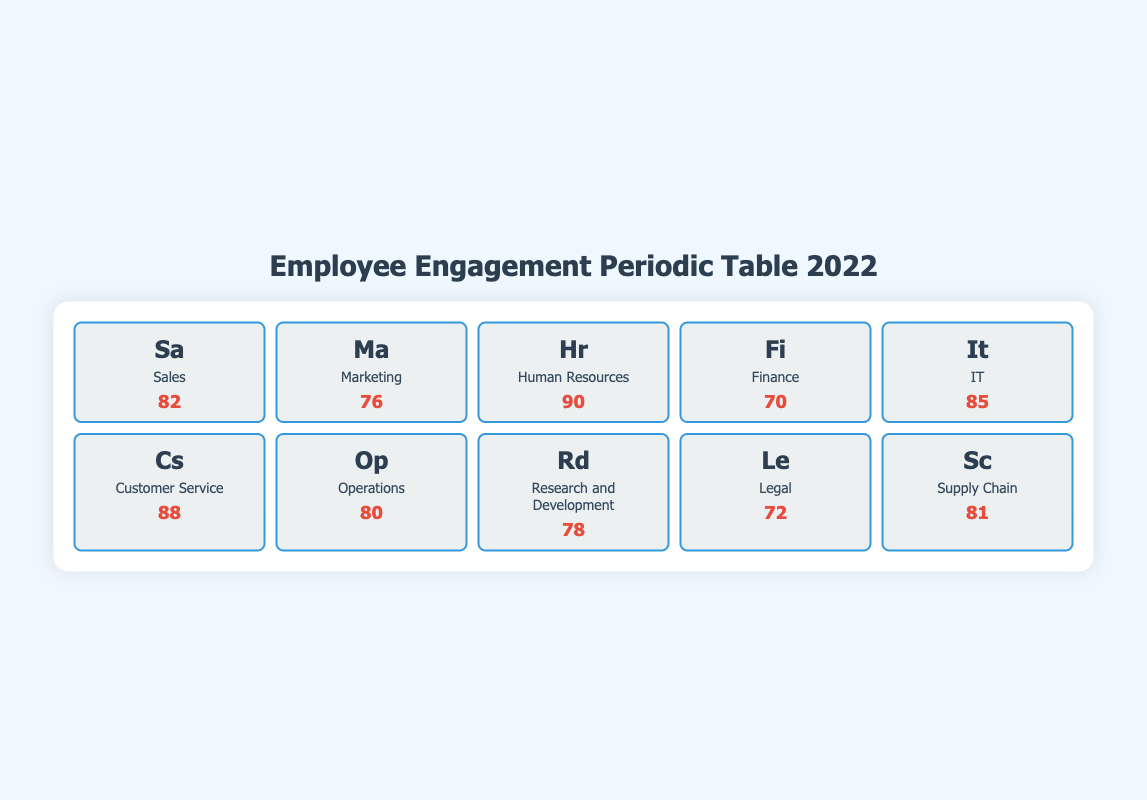What is the highest employee engagement score among the departments? The employee engagement scores listed in the table range from 70 to 90. The highest score is 90 from the Human Resources department.
Answer: 90 Which department has the lowest employee engagement score? The table lists various departments with their respective engagement scores. The department with the lowest score is Finance, which has a score of 70.
Answer: Finance What is the average employee engagement score for the Marketing and Operations departments? The scores for Marketing and Operations are 76 and 80 respectively. To find the average, add the two scores (76 + 80 = 156) and then divide by the number of departments (156 / 2 = 78).
Answer: 78 Is the score for Customer Service higher than that for Operations? The Employee Engagement Score for Customer Service is 88, while Operations has a score of 80. Since 88 is greater than 80, the statement is true.
Answer: Yes Which department has a score of 85, and what is the highlight associated with it? The table lists the IT department with a score of 85. Its highlight mentions that Agile methodologies promote teamwork and engagement.
Answer: IT, Agile methodologies promote teamwork and engagement What is the difference between the highest and lowest scores in the table? The highest score is 90 (Human Resources), and the lowest score is 70 (Finance). The difference is calculated by subtracting the lowest score from the highest score (90 - 70 = 20).
Answer: 20 Are there more departments with scores above 80 than below 80? By looking at the scores, there are departments above 80: Sales (82), IT (85), Customer Service (88), Operations (80), and Supply Chain (81). For departments below 80, we have Marketing (76), Finance (70), Research and Development (78), and Legal (72), making it 5 above 80 and 4 below 80. Thus, the statement is true.
Answer: Yes What score did the Research and Development department achieve? From the table, the Research and Development department achieved a score of 78.
Answer: 78 What is the total score of the Human Resources, Customer Service, and IT departments combined? The scores for these departments are as follows: Human Resources (90), Customer Service (88), and IT (85). Adding these together gives us 90 + 88 + 85 = 263.
Answer: 263 Which departments have a score of 80 or above? The departments with scores of 80 or above include Sales (82), IT (85), Customer Service (88), Operations (80), and Supply Chain (81).
Answer: Sales, IT, Customer Service, Operations, Supply Chain 